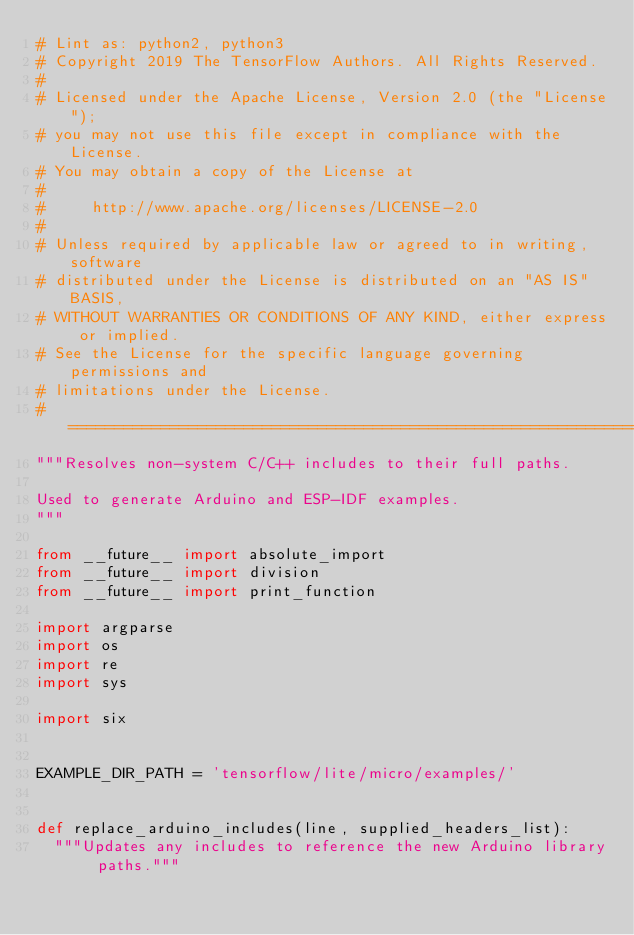Convert code to text. <code><loc_0><loc_0><loc_500><loc_500><_Python_># Lint as: python2, python3
# Copyright 2019 The TensorFlow Authors. All Rights Reserved.
#
# Licensed under the Apache License, Version 2.0 (the "License");
# you may not use this file except in compliance with the License.
# You may obtain a copy of the License at
#
#     http://www.apache.org/licenses/LICENSE-2.0
#
# Unless required by applicable law or agreed to in writing, software
# distributed under the License is distributed on an "AS IS" BASIS,
# WITHOUT WARRANTIES OR CONDITIONS OF ANY KIND, either express or implied.
# See the License for the specific language governing permissions and
# limitations under the License.
# ==============================================================================
"""Resolves non-system C/C++ includes to their full paths.

Used to generate Arduino and ESP-IDF examples.
"""

from __future__ import absolute_import
from __future__ import division
from __future__ import print_function

import argparse
import os
import re
import sys

import six


EXAMPLE_DIR_PATH = 'tensorflow/lite/micro/examples/'


def replace_arduino_includes(line, supplied_headers_list):
  """Updates any includes to reference the new Arduino library paths."""</code> 